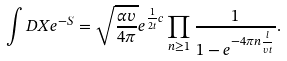Convert formula to latex. <formula><loc_0><loc_0><loc_500><loc_500>\int D X e ^ { - S } = \sqrt { \frac { \alpha v } { 4 \pi } } e ^ { \frac { 1 } { 2 t } c } \prod _ { n \geq 1 } \frac { 1 } { 1 - e ^ { - 4 \pi n \frac { l } { v t } } } .</formula> 